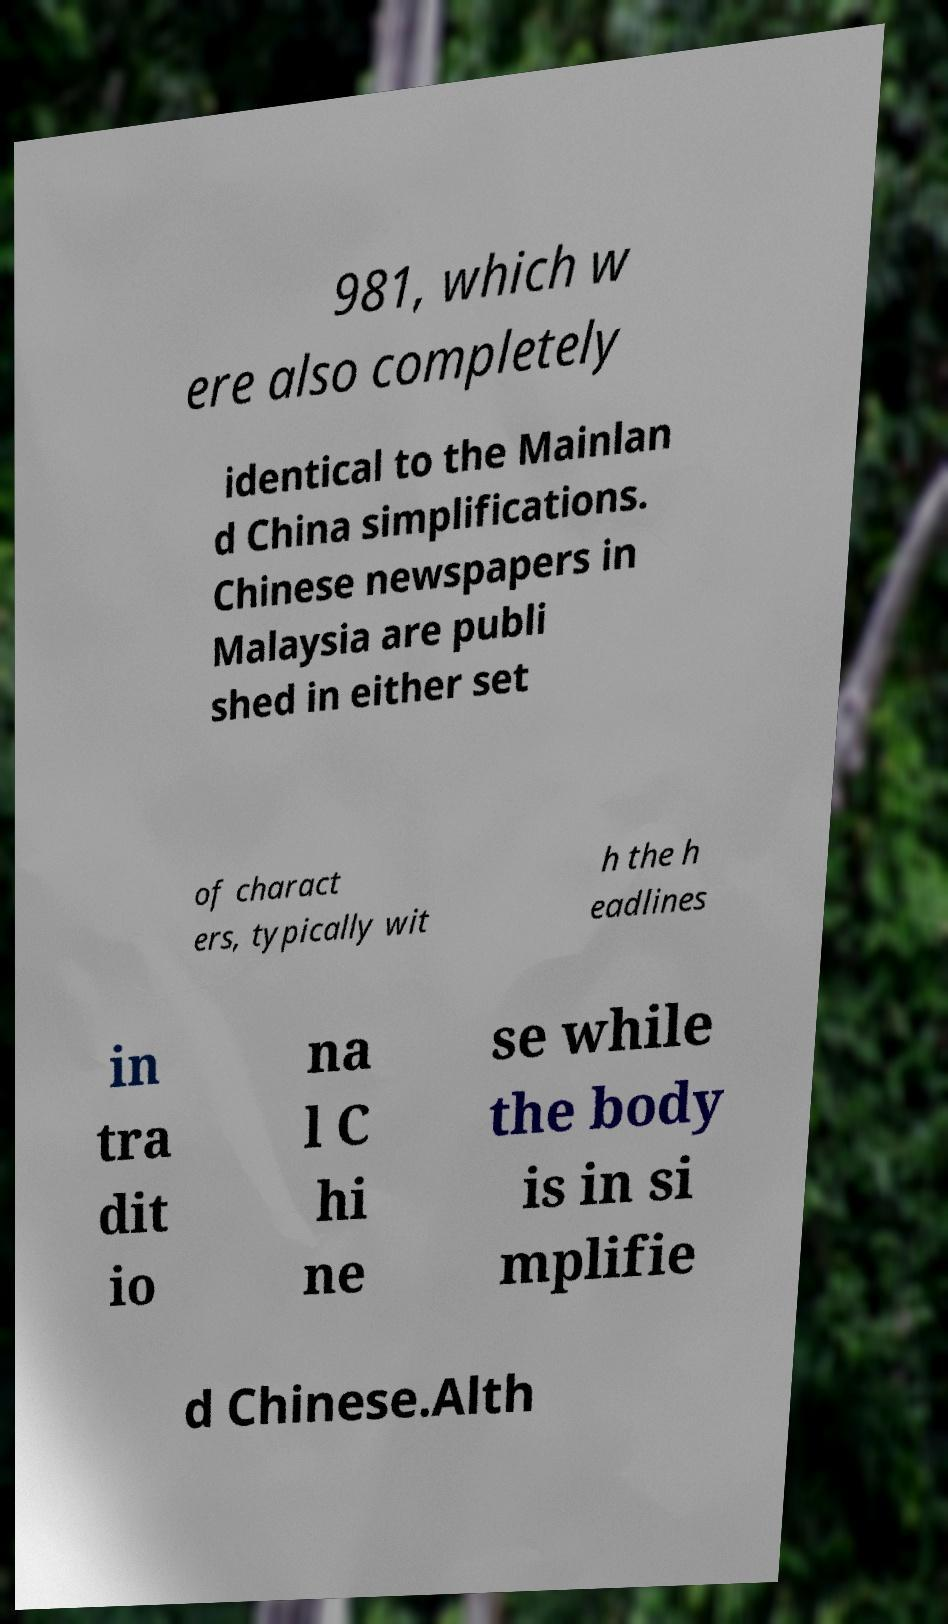I need the written content from this picture converted into text. Can you do that? 981, which w ere also completely identical to the Mainlan d China simplifications. Chinese newspapers in Malaysia are publi shed in either set of charact ers, typically wit h the h eadlines in tra dit io na l C hi ne se while the body is in si mplifie d Chinese.Alth 